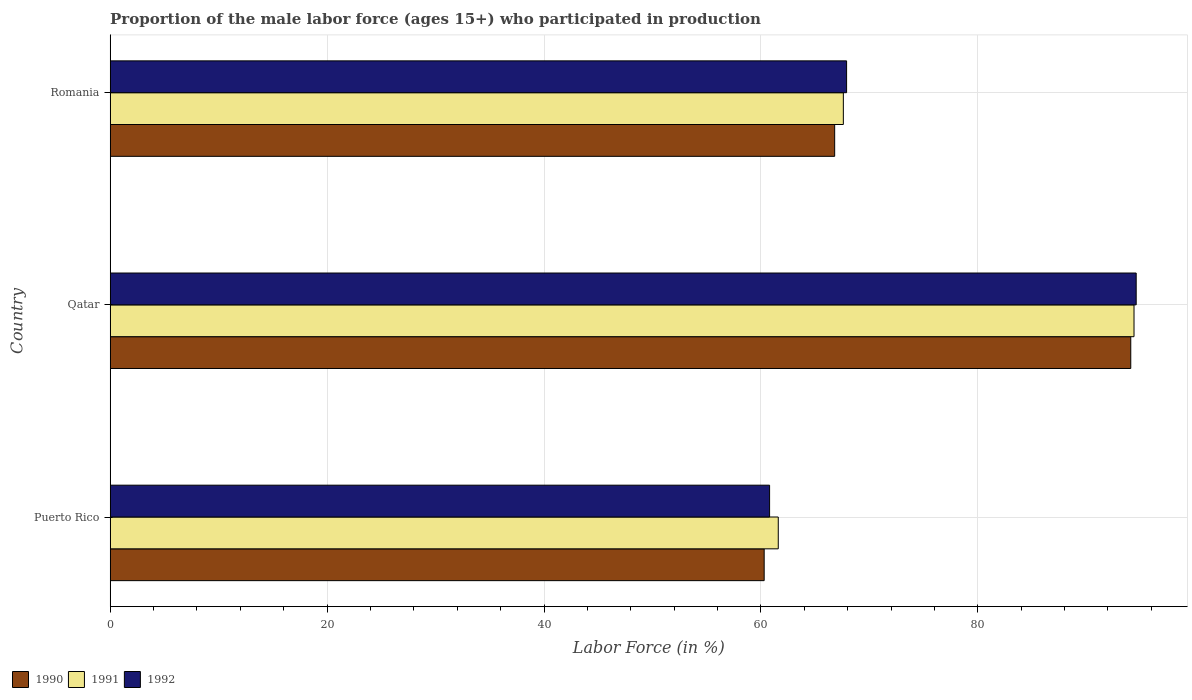How many different coloured bars are there?
Your answer should be very brief. 3. Are the number of bars per tick equal to the number of legend labels?
Provide a succinct answer. Yes. How many bars are there on the 1st tick from the top?
Provide a succinct answer. 3. How many bars are there on the 3rd tick from the bottom?
Your answer should be compact. 3. What is the label of the 1st group of bars from the top?
Ensure brevity in your answer.  Romania. What is the proportion of the male labor force who participated in production in 1991 in Qatar?
Ensure brevity in your answer.  94.4. Across all countries, what is the maximum proportion of the male labor force who participated in production in 1991?
Offer a very short reply. 94.4. Across all countries, what is the minimum proportion of the male labor force who participated in production in 1991?
Keep it short and to the point. 61.6. In which country was the proportion of the male labor force who participated in production in 1991 maximum?
Keep it short and to the point. Qatar. In which country was the proportion of the male labor force who participated in production in 1991 minimum?
Offer a very short reply. Puerto Rico. What is the total proportion of the male labor force who participated in production in 1992 in the graph?
Offer a terse response. 223.3. What is the difference between the proportion of the male labor force who participated in production in 1990 in Puerto Rico and that in Romania?
Provide a short and direct response. -6.5. What is the difference between the proportion of the male labor force who participated in production in 1992 in Qatar and the proportion of the male labor force who participated in production in 1991 in Puerto Rico?
Provide a short and direct response. 33. What is the average proportion of the male labor force who participated in production in 1992 per country?
Keep it short and to the point. 74.43. In how many countries, is the proportion of the male labor force who participated in production in 1991 greater than 76 %?
Keep it short and to the point. 1. What is the ratio of the proportion of the male labor force who participated in production in 1990 in Puerto Rico to that in Romania?
Provide a succinct answer. 0.9. Is the proportion of the male labor force who participated in production in 1992 in Puerto Rico less than that in Romania?
Your answer should be compact. Yes. What is the difference between the highest and the second highest proportion of the male labor force who participated in production in 1990?
Provide a succinct answer. 27.3. What is the difference between the highest and the lowest proportion of the male labor force who participated in production in 1992?
Give a very brief answer. 33.8. Is the sum of the proportion of the male labor force who participated in production in 1992 in Puerto Rico and Qatar greater than the maximum proportion of the male labor force who participated in production in 1991 across all countries?
Offer a terse response. Yes. What does the 2nd bar from the bottom in Romania represents?
Offer a terse response. 1991. How many countries are there in the graph?
Your answer should be compact. 3. What is the difference between two consecutive major ticks on the X-axis?
Make the answer very short. 20. Are the values on the major ticks of X-axis written in scientific E-notation?
Your response must be concise. No. Where does the legend appear in the graph?
Ensure brevity in your answer.  Bottom left. What is the title of the graph?
Make the answer very short. Proportion of the male labor force (ages 15+) who participated in production. What is the label or title of the X-axis?
Offer a terse response. Labor Force (in %). What is the Labor Force (in %) in 1990 in Puerto Rico?
Offer a terse response. 60.3. What is the Labor Force (in %) in 1991 in Puerto Rico?
Ensure brevity in your answer.  61.6. What is the Labor Force (in %) of 1992 in Puerto Rico?
Your answer should be very brief. 60.8. What is the Labor Force (in %) of 1990 in Qatar?
Make the answer very short. 94.1. What is the Labor Force (in %) in 1991 in Qatar?
Your answer should be very brief. 94.4. What is the Labor Force (in %) in 1992 in Qatar?
Your answer should be very brief. 94.6. What is the Labor Force (in %) of 1990 in Romania?
Your answer should be very brief. 66.8. What is the Labor Force (in %) in 1991 in Romania?
Offer a terse response. 67.6. What is the Labor Force (in %) in 1992 in Romania?
Provide a short and direct response. 67.9. Across all countries, what is the maximum Labor Force (in %) in 1990?
Give a very brief answer. 94.1. Across all countries, what is the maximum Labor Force (in %) of 1991?
Keep it short and to the point. 94.4. Across all countries, what is the maximum Labor Force (in %) in 1992?
Ensure brevity in your answer.  94.6. Across all countries, what is the minimum Labor Force (in %) in 1990?
Give a very brief answer. 60.3. Across all countries, what is the minimum Labor Force (in %) in 1991?
Keep it short and to the point. 61.6. Across all countries, what is the minimum Labor Force (in %) of 1992?
Your answer should be very brief. 60.8. What is the total Labor Force (in %) of 1990 in the graph?
Provide a short and direct response. 221.2. What is the total Labor Force (in %) of 1991 in the graph?
Your answer should be compact. 223.6. What is the total Labor Force (in %) in 1992 in the graph?
Your answer should be compact. 223.3. What is the difference between the Labor Force (in %) in 1990 in Puerto Rico and that in Qatar?
Your answer should be very brief. -33.8. What is the difference between the Labor Force (in %) in 1991 in Puerto Rico and that in Qatar?
Your response must be concise. -32.8. What is the difference between the Labor Force (in %) of 1992 in Puerto Rico and that in Qatar?
Provide a short and direct response. -33.8. What is the difference between the Labor Force (in %) of 1990 in Puerto Rico and that in Romania?
Provide a succinct answer. -6.5. What is the difference between the Labor Force (in %) in 1991 in Puerto Rico and that in Romania?
Keep it short and to the point. -6. What is the difference between the Labor Force (in %) of 1990 in Qatar and that in Romania?
Give a very brief answer. 27.3. What is the difference between the Labor Force (in %) in 1991 in Qatar and that in Romania?
Provide a succinct answer. 26.8. What is the difference between the Labor Force (in %) of 1992 in Qatar and that in Romania?
Make the answer very short. 26.7. What is the difference between the Labor Force (in %) in 1990 in Puerto Rico and the Labor Force (in %) in 1991 in Qatar?
Your answer should be very brief. -34.1. What is the difference between the Labor Force (in %) in 1990 in Puerto Rico and the Labor Force (in %) in 1992 in Qatar?
Ensure brevity in your answer.  -34.3. What is the difference between the Labor Force (in %) of 1991 in Puerto Rico and the Labor Force (in %) of 1992 in Qatar?
Your response must be concise. -33. What is the difference between the Labor Force (in %) in 1990 in Puerto Rico and the Labor Force (in %) in 1991 in Romania?
Ensure brevity in your answer.  -7.3. What is the difference between the Labor Force (in %) in 1990 in Puerto Rico and the Labor Force (in %) in 1992 in Romania?
Your answer should be compact. -7.6. What is the difference between the Labor Force (in %) of 1990 in Qatar and the Labor Force (in %) of 1991 in Romania?
Provide a short and direct response. 26.5. What is the difference between the Labor Force (in %) of 1990 in Qatar and the Labor Force (in %) of 1992 in Romania?
Keep it short and to the point. 26.2. What is the average Labor Force (in %) of 1990 per country?
Ensure brevity in your answer.  73.73. What is the average Labor Force (in %) of 1991 per country?
Offer a very short reply. 74.53. What is the average Labor Force (in %) in 1992 per country?
Ensure brevity in your answer.  74.43. What is the difference between the Labor Force (in %) in 1991 and Labor Force (in %) in 1992 in Puerto Rico?
Your answer should be very brief. 0.8. What is the difference between the Labor Force (in %) of 1990 and Labor Force (in %) of 1992 in Qatar?
Offer a very short reply. -0.5. What is the difference between the Labor Force (in %) of 1991 and Labor Force (in %) of 1992 in Romania?
Keep it short and to the point. -0.3. What is the ratio of the Labor Force (in %) in 1990 in Puerto Rico to that in Qatar?
Your answer should be compact. 0.64. What is the ratio of the Labor Force (in %) of 1991 in Puerto Rico to that in Qatar?
Offer a terse response. 0.65. What is the ratio of the Labor Force (in %) in 1992 in Puerto Rico to that in Qatar?
Provide a short and direct response. 0.64. What is the ratio of the Labor Force (in %) of 1990 in Puerto Rico to that in Romania?
Make the answer very short. 0.9. What is the ratio of the Labor Force (in %) in 1991 in Puerto Rico to that in Romania?
Provide a short and direct response. 0.91. What is the ratio of the Labor Force (in %) of 1992 in Puerto Rico to that in Romania?
Provide a short and direct response. 0.9. What is the ratio of the Labor Force (in %) of 1990 in Qatar to that in Romania?
Provide a short and direct response. 1.41. What is the ratio of the Labor Force (in %) of 1991 in Qatar to that in Romania?
Offer a terse response. 1.4. What is the ratio of the Labor Force (in %) of 1992 in Qatar to that in Romania?
Offer a very short reply. 1.39. What is the difference between the highest and the second highest Labor Force (in %) in 1990?
Give a very brief answer. 27.3. What is the difference between the highest and the second highest Labor Force (in %) in 1991?
Keep it short and to the point. 26.8. What is the difference between the highest and the second highest Labor Force (in %) of 1992?
Your response must be concise. 26.7. What is the difference between the highest and the lowest Labor Force (in %) in 1990?
Provide a short and direct response. 33.8. What is the difference between the highest and the lowest Labor Force (in %) of 1991?
Provide a succinct answer. 32.8. What is the difference between the highest and the lowest Labor Force (in %) of 1992?
Your answer should be very brief. 33.8. 